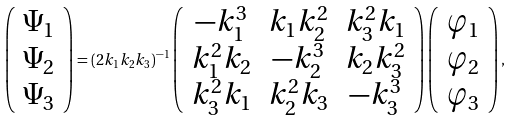<formula> <loc_0><loc_0><loc_500><loc_500>\left ( \begin{array} { c } \Psi _ { 1 } \\ \Psi _ { 2 } \\ \Psi _ { 3 } \\ \end{array} \right ) = ( 2 k _ { 1 } k _ { 2 } k _ { 3 } ) ^ { - 1 } \left ( \begin{array} { c c c } - k _ { 1 } ^ { 3 } & k _ { 1 } k _ { 2 } ^ { 2 } & k _ { 3 } ^ { 2 } k _ { 1 } \\ k _ { 1 } ^ { 2 } k _ { 2 } & - k _ { 2 } ^ { 3 } & k _ { 2 } k _ { 3 } ^ { 2 } \\ k _ { 3 } ^ { 2 } k _ { 1 } & k _ { 2 } ^ { 2 } k _ { 3 } & - k _ { 3 } ^ { 3 } \\ \end{array} \right ) \left ( \begin{array} { c } \varphi _ { 1 } \\ \varphi _ { 2 } \\ \varphi _ { 3 } \\ \end{array} \right ) ,</formula> 